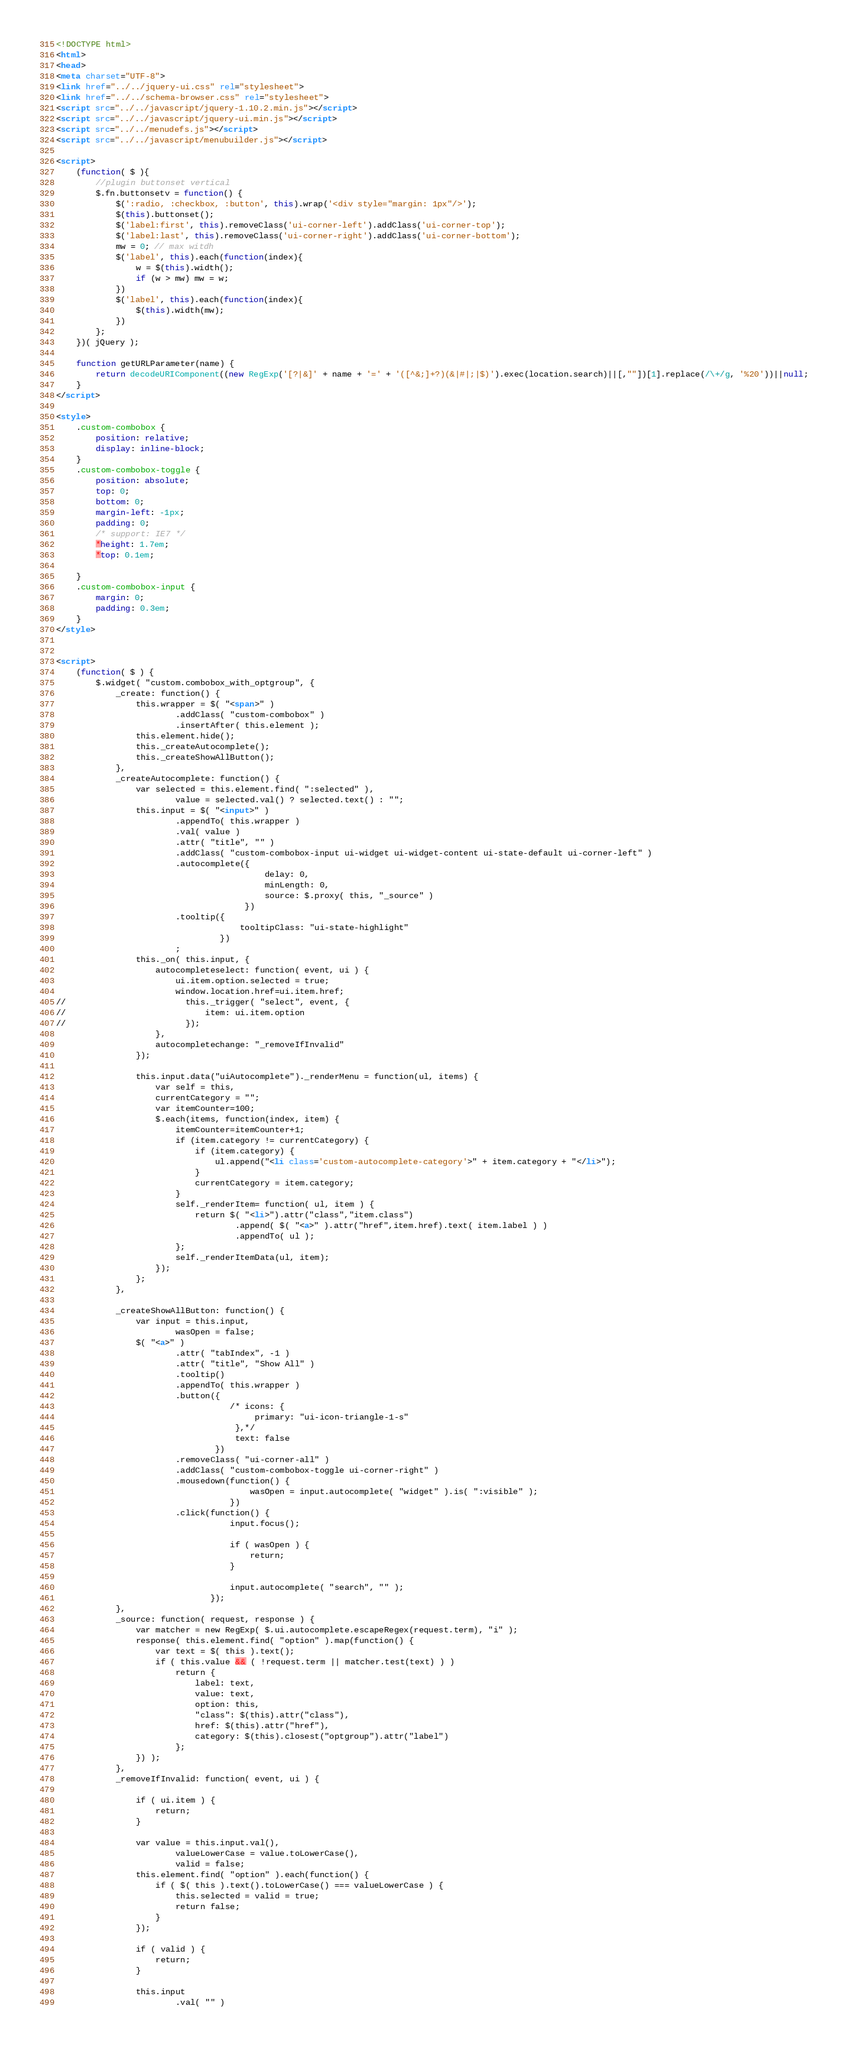<code> <loc_0><loc_0><loc_500><loc_500><_HTML_><!DOCTYPE html>
<html>
<head>
<meta charset="UTF-8">
<link href="../../jquery-ui.css" rel="stylesheet">
<link href="../../schema-browser.css" rel="stylesheet">
<script src="../../javascript/jquery-1.10.2.min.js"></script>
<script src="../../javascript/jquery-ui.min.js"></script>
<script src="../../menudefs.js"></script>
<script src="../../javascript/menubuilder.js"></script>

<script>
    (function( $ ){
        //plugin buttonset vertical
        $.fn.buttonsetv = function() {
            $(':radio, :checkbox, :button', this).wrap('<div style="margin: 1px"/>');
            $(this).buttonset();
            $('label:first', this).removeClass('ui-corner-left').addClass('ui-corner-top');
            $('label:last', this).removeClass('ui-corner-right').addClass('ui-corner-bottom');
            mw = 0; // max witdh
            $('label', this).each(function(index){
                w = $(this).width();
                if (w > mw) mw = w;
            })
            $('label', this).each(function(index){
                $(this).width(mw);
            })
        };
    })( jQuery );

    function getURLParameter(name) {
        return decodeURIComponent((new RegExp('[?|&]' + name + '=' + '([^&;]+?)(&|#|;|$)').exec(location.search)||[,""])[1].replace(/\+/g, '%20'))||null;
    }
</script>

<style>
    .custom-combobox {
        position: relative;
        display: inline-block;
    }
    .custom-combobox-toggle {
        position: absolute;
        top: 0;
        bottom: 0;
        margin-left: -1px;
        padding: 0;
        /* support: IE7 */
        *height: 1.7em;
        *top: 0.1em;

    }
    .custom-combobox-input {
        margin: 0;
        padding: 0.3em;
    }
</style>


<script>
    (function( $ ) {
        $.widget( "custom.combobox_with_optgroup", {
            _create: function() {
                this.wrapper = $( "<span>" )
                        .addClass( "custom-combobox" )
                        .insertAfter( this.element );
                this.element.hide();
                this._createAutocomplete();
                this._createShowAllButton();
            },
            _createAutocomplete: function() {
                var selected = this.element.find( ":selected" ),
                        value = selected.val() ? selected.text() : "";
                this.input = $( "<input>" )
                        .appendTo( this.wrapper )
                        .val( value )
                        .attr( "title", "" )
                        .addClass( "custom-combobox-input ui-widget ui-widget-content ui-state-default ui-corner-left" )
                        .autocomplete({
                                          delay: 0,
                                          minLength: 0,
                                          source: $.proxy( this, "_source" )
                                      })
                        .tooltip({
                                     tooltipClass: "ui-state-highlight"
                                 })
                        ;
                this._on( this.input, {
                    autocompleteselect: function( event, ui ) {
                        ui.item.option.selected = true;
                        window.location.href=ui.item.href;
//                        this._trigger( "select", event, {
//                            item: ui.item.option
//                        });
                    },
                    autocompletechange: "_removeIfInvalid"
                });

                this.input.data("uiAutocomplete")._renderMenu = function(ul, items) {
                    var self = this,
                    currentCategory = "";
                    var itemCounter=100;
                    $.each(items, function(index, item) {
                        itemCounter=itemCounter+1;
                        if (item.category != currentCategory) {
                            if (item.category) {
                                ul.append("<li class='custom-autocomplete-category'>" + item.category + "</li>");
                            }
                            currentCategory = item.category;
                        }
                        self._renderItem= function( ul, item ) {
                            return $( "<li>").attr("class","item.class")
                                    .append( $( "<a>" ).attr("href",item.href).text( item.label ) )
                                    .appendTo( ul );
                        };
                        self._renderItemData(ul, item);
                    });
                };
            },

            _createShowAllButton: function() {
                var input = this.input,
                        wasOpen = false;
                $( "<a>" )
                        .attr( "tabIndex", -1 )
                        .attr( "title", "Show All" )
                        .tooltip()
                        .appendTo( this.wrapper )
                        .button({
                                   /* icons: {
                                        primary: "ui-icon-triangle-1-s"
                                    },*/
                                    text: false
                                })
                        .removeClass( "ui-corner-all" )
                        .addClass( "custom-combobox-toggle ui-corner-right" )
                        .mousedown(function() {
                                       wasOpen = input.autocomplete( "widget" ).is( ":visible" );
                                   })
                        .click(function() {
                                   input.focus();

                                   if ( wasOpen ) {
                                       return;
                                   }

                                   input.autocomplete( "search", "" );
                               });
            },
            _source: function( request, response ) {
                var matcher = new RegExp( $.ui.autocomplete.escapeRegex(request.term), "i" );
                response( this.element.find( "option" ).map(function() {
                    var text = $( this ).text();
                    if ( this.value && ( !request.term || matcher.test(text) ) )
                        return {
                            label: text,
                            value: text,
                            option: this,
                            "class": $(this).attr("class"),
                            href: $(this).attr("href"),
                            category: $(this).closest("optgroup").attr("label")
                        };
                }) );
            },
            _removeIfInvalid: function( event, ui ) {

                if ( ui.item ) {
                    return;
                }

                var value = this.input.val(),
                        valueLowerCase = value.toLowerCase(),
                        valid = false;
                this.element.find( "option" ).each(function() {
                    if ( $( this ).text().toLowerCase() === valueLowerCase ) {
                        this.selected = valid = true;
                        return false;
                    }
                });

                if ( valid ) {
                    return;
                }

                this.input
                        .val( "" )</code> 